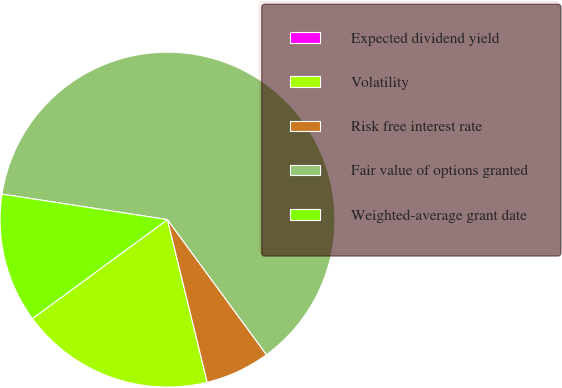Convert chart to OTSL. <chart><loc_0><loc_0><loc_500><loc_500><pie_chart><fcel>Expected dividend yield<fcel>Volatility<fcel>Risk free interest rate<fcel>Fair value of options granted<fcel>Weighted-average grant date<nl><fcel>0.0%<fcel>18.75%<fcel>6.25%<fcel>62.5%<fcel>12.5%<nl></chart> 